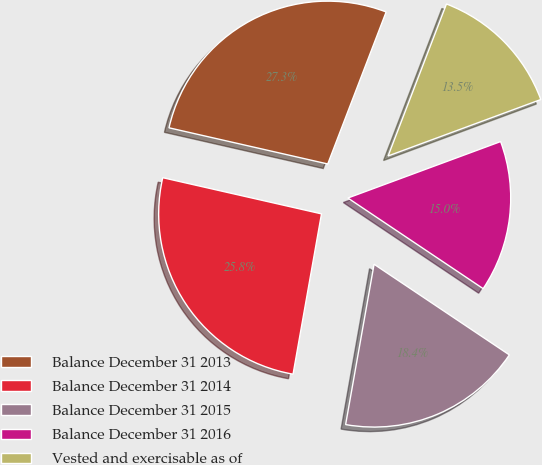<chart> <loc_0><loc_0><loc_500><loc_500><pie_chart><fcel>Balance December 31 2013<fcel>Balance December 31 2014<fcel>Balance December 31 2015<fcel>Balance December 31 2016<fcel>Vested and exercisable as of<nl><fcel>27.27%<fcel>25.77%<fcel>18.4%<fcel>15.03%<fcel>13.53%<nl></chart> 